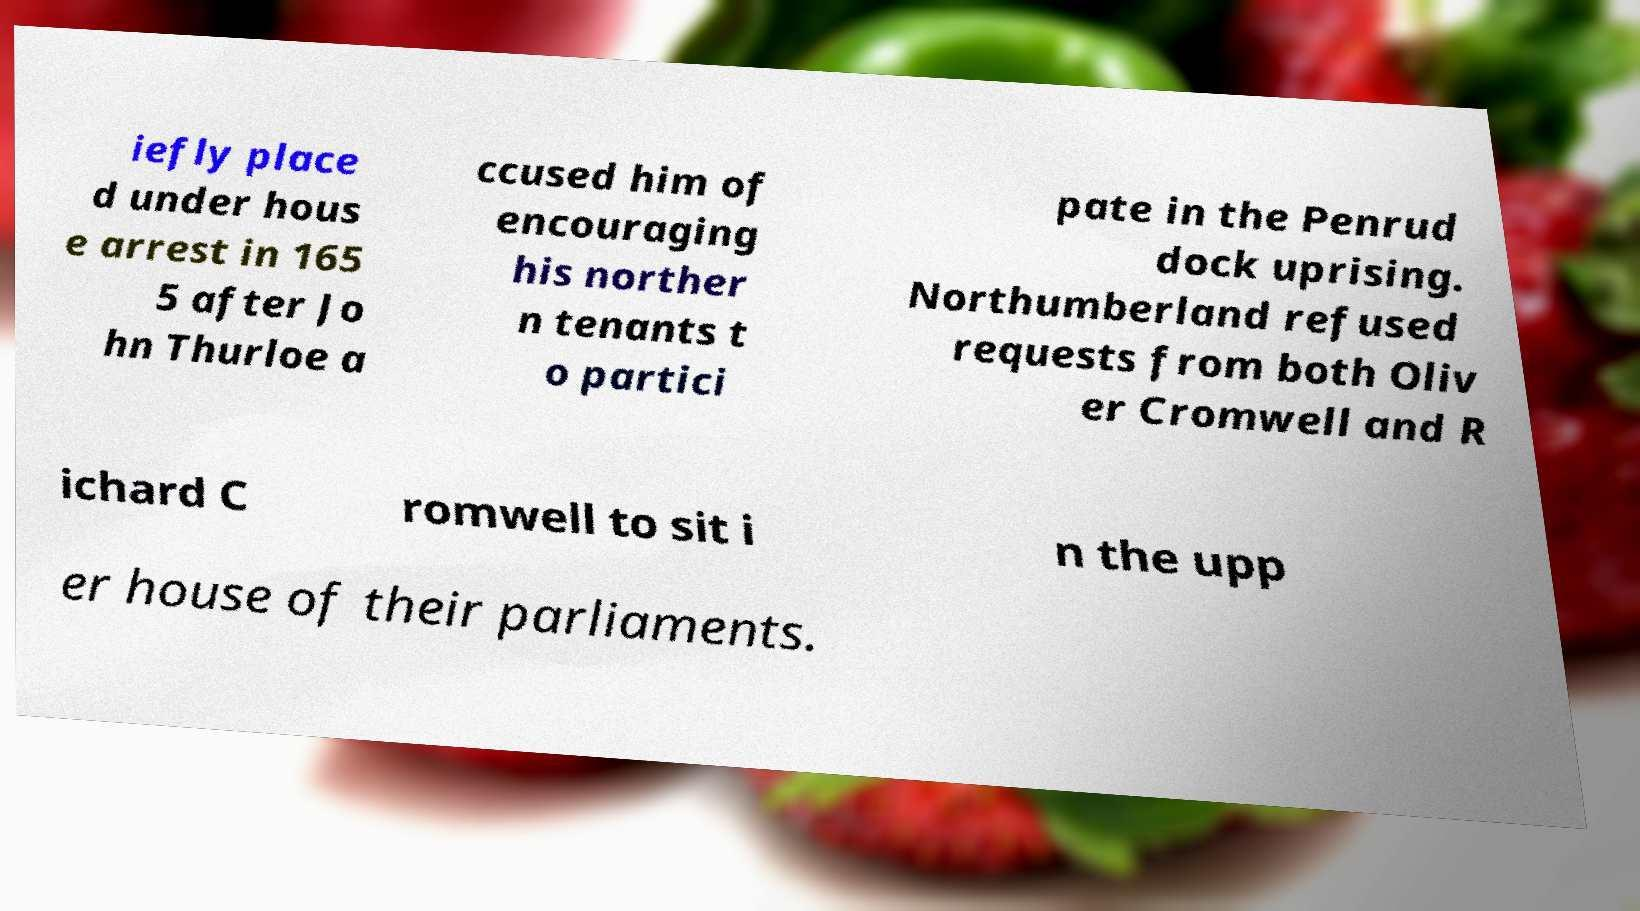There's text embedded in this image that I need extracted. Can you transcribe it verbatim? iefly place d under hous e arrest in 165 5 after Jo hn Thurloe a ccused him of encouraging his norther n tenants t o partici pate in the Penrud dock uprising. Northumberland refused requests from both Oliv er Cromwell and R ichard C romwell to sit i n the upp er house of their parliaments. 